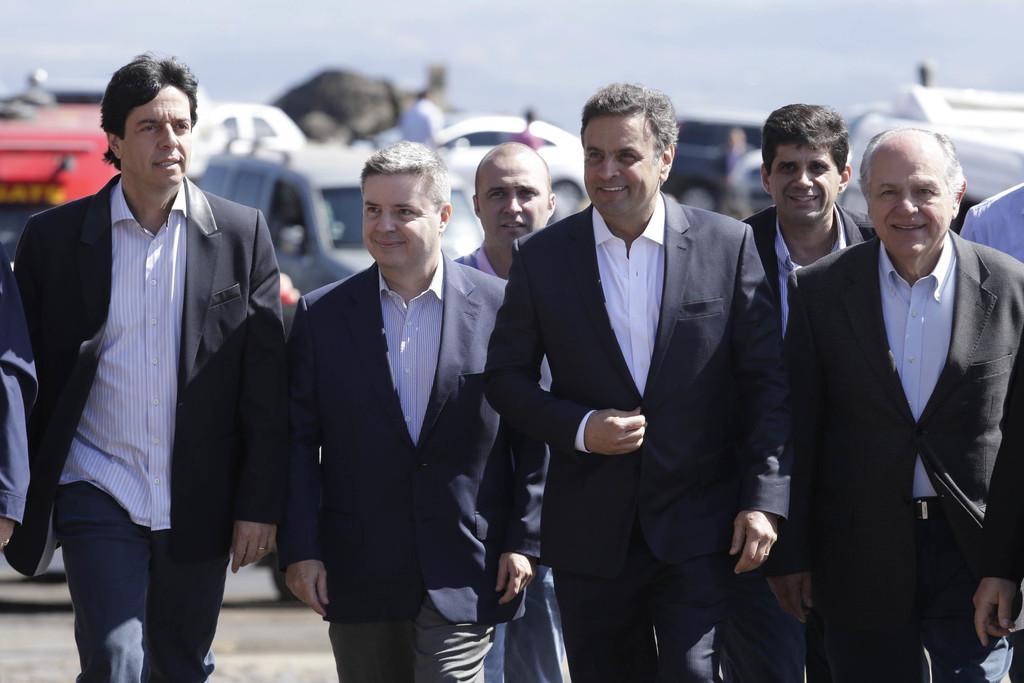Can you describe this image briefly? In this image I can see there are group of persons they are smiling and they are wearing a black color suits and in the background I can see the vehicle and the sky. 